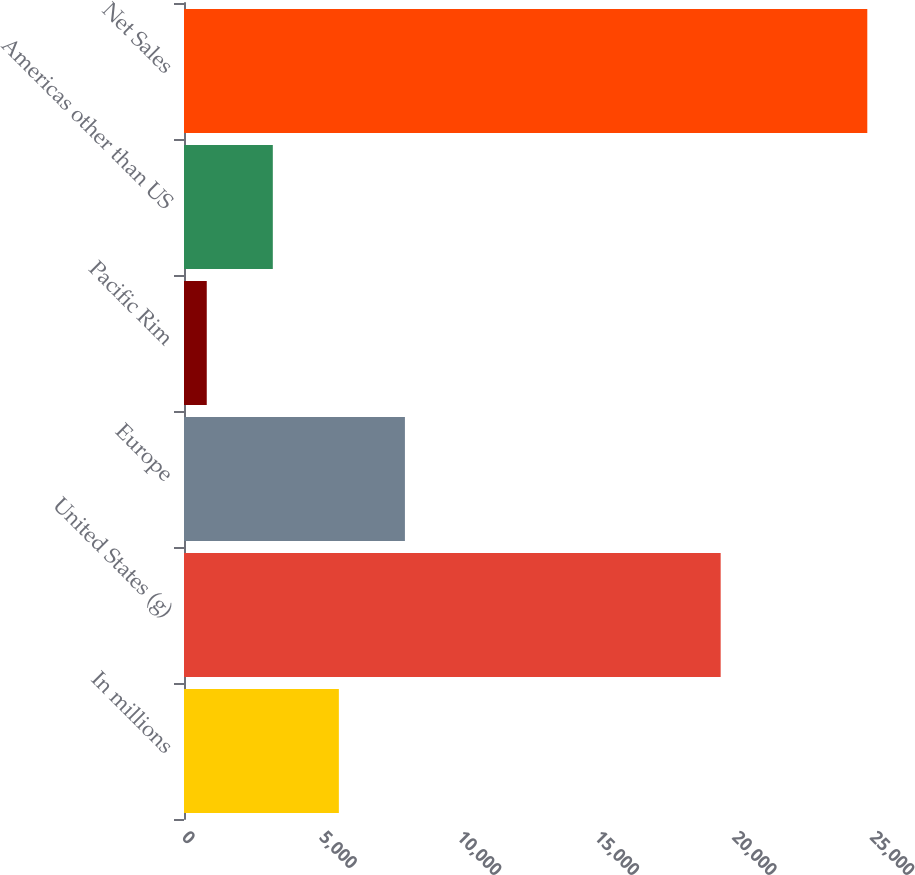<chart> <loc_0><loc_0><loc_500><loc_500><bar_chart><fcel>In millions<fcel>United States (g)<fcel>Europe<fcel>Pacific Rim<fcel>Americas other than US<fcel>Net Sales<nl><fcel>5627.4<fcel>19501<fcel>8027.6<fcel>827<fcel>3227.2<fcel>24829<nl></chart> 